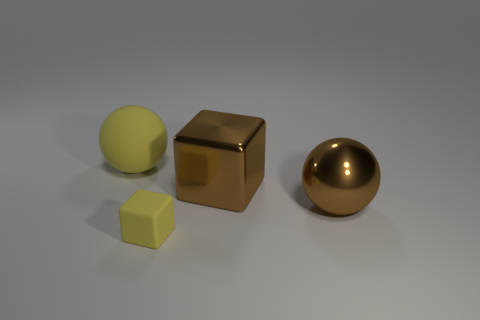Is there any other thing that is the same size as the metal cube?
Your response must be concise. Yes. There is another thing that is the same shape as the small yellow object; what is its size?
Keep it short and to the point. Large. Are there more large metallic cubes in front of the large metallic ball than large brown metal objects that are in front of the metallic block?
Your answer should be very brief. No. Does the brown block have the same material as the sphere that is to the right of the large yellow thing?
Offer a very short reply. Yes. Is there any other thing that has the same shape as the tiny object?
Your answer should be very brief. Yes. What color is the thing that is to the left of the large metal block and behind the yellow rubber cube?
Make the answer very short. Yellow. What is the shape of the yellow rubber thing that is on the left side of the rubber cube?
Your answer should be very brief. Sphere. There is a yellow rubber object that is in front of the large ball behind the big brown thing that is to the right of the large cube; how big is it?
Offer a terse response. Small. How many brown metallic objects are behind the brown shiny object in front of the big brown shiny block?
Offer a terse response. 1. There is a object that is in front of the brown shiny cube and behind the tiny yellow thing; what size is it?
Offer a terse response. Large. 